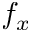Convert formula to latex. <formula><loc_0><loc_0><loc_500><loc_500>f _ { x }</formula> 